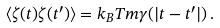<formula> <loc_0><loc_0><loc_500><loc_500>\langle \zeta ( t ) \zeta ( t ^ { \prime } ) \rangle = k _ { B } T m \gamma ( | t - t ^ { \prime } | ) \, .</formula> 